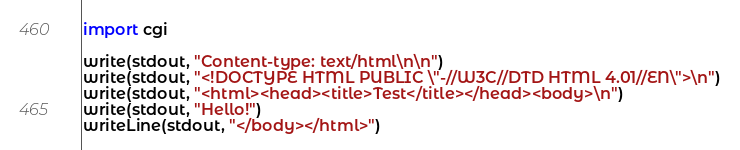Convert code to text. <code><loc_0><loc_0><loc_500><loc_500><_Nim_>import cgi

write(stdout, "Content-type: text/html\n\n")
write(stdout, "<!DOCTYPE HTML PUBLIC \"-//W3C//DTD HTML 4.01//EN\">\n")
write(stdout, "<html><head><title>Test</title></head><body>\n")
write(stdout, "Hello!")
writeLine(stdout, "</body></html>")
</code> 